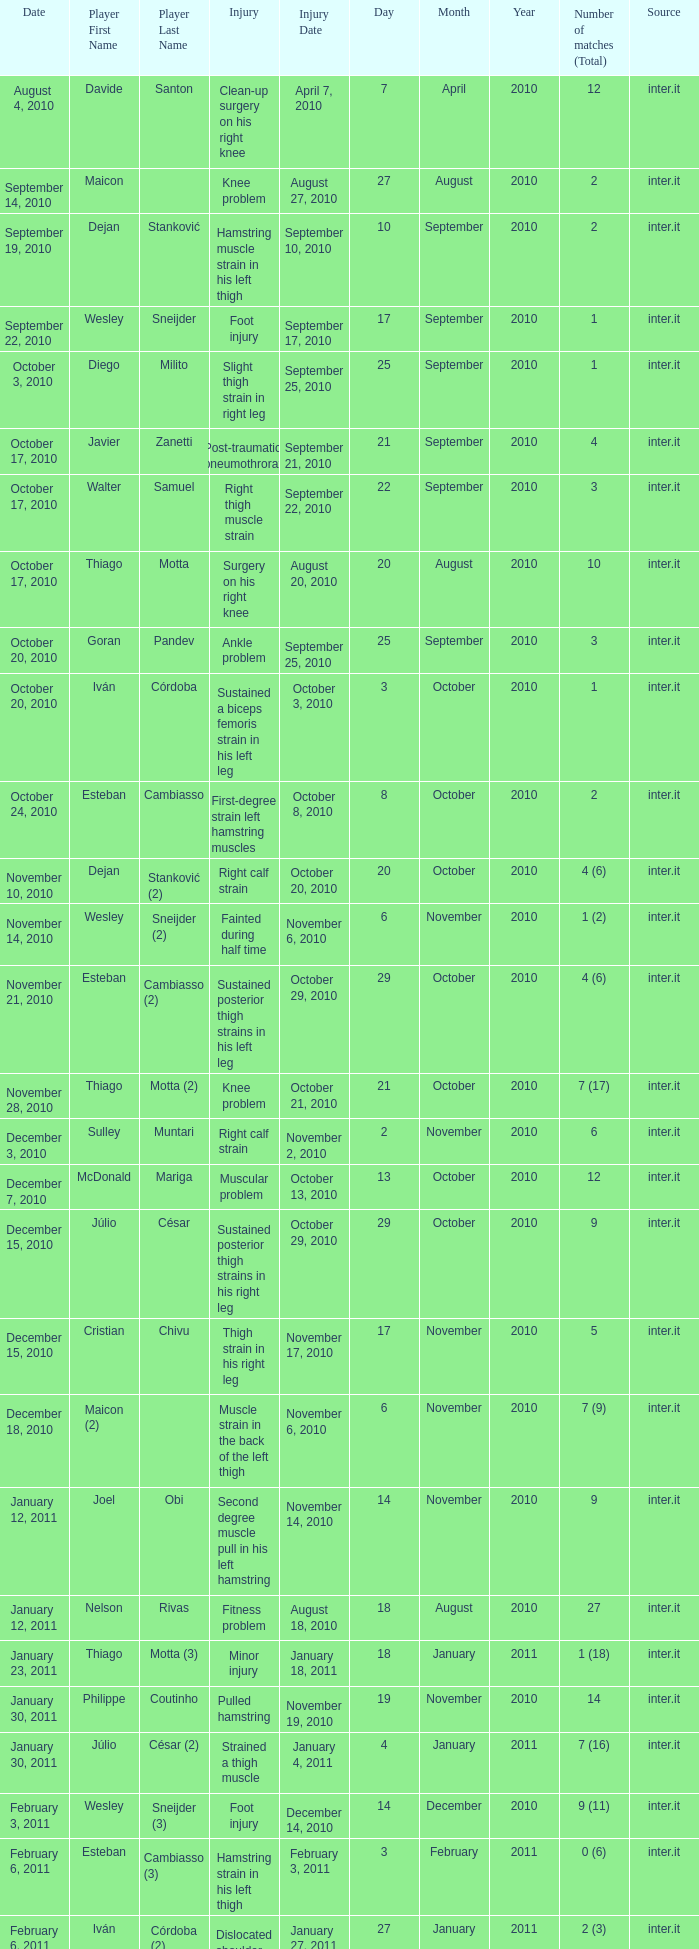What is the date of injury when the injury is sustained posterior thigh strains in his left leg? October 29, 2010. 